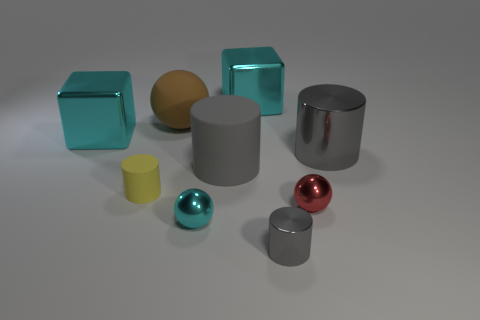Subtract all purple spheres. How many gray cylinders are left? 3 Subtract all green cylinders. Subtract all green cubes. How many cylinders are left? 4 Subtract all cylinders. How many objects are left? 5 Add 1 brown objects. How many brown objects are left? 2 Add 4 tiny spheres. How many tiny spheres exist? 6 Subtract 1 brown balls. How many objects are left? 8 Subtract all big red matte objects. Subtract all large cyan metallic things. How many objects are left? 7 